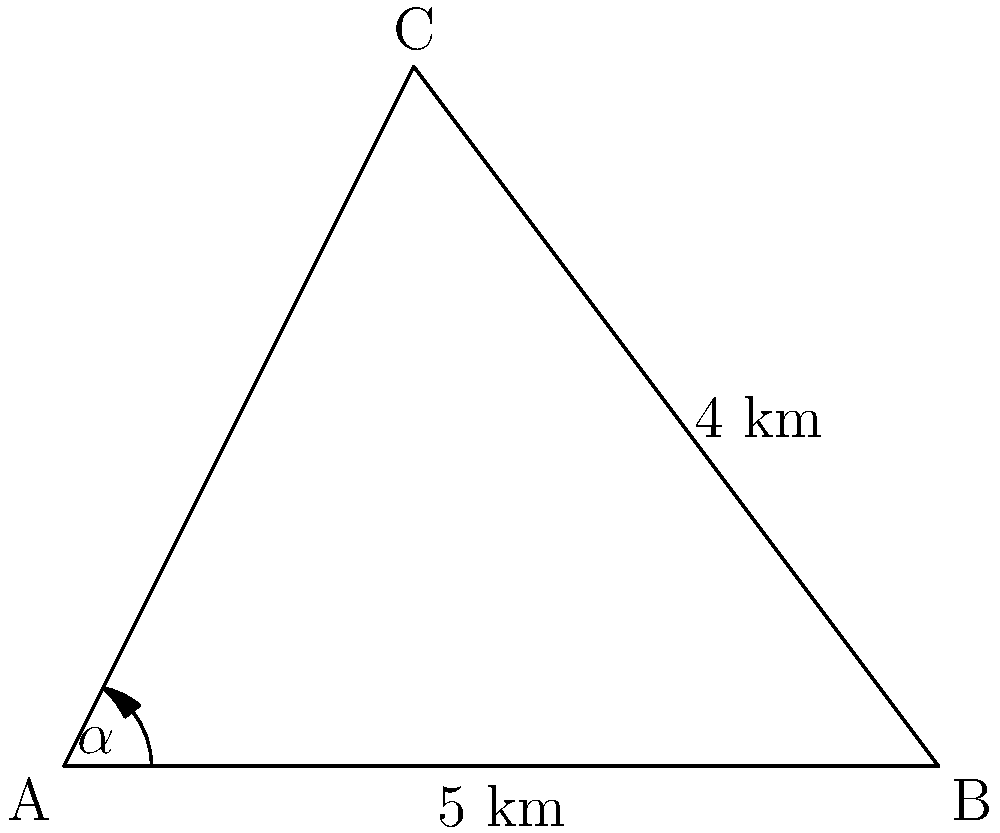As a tech-savvy parent, you're helping your child with a school project about local landmarks. You're standing at point A, and you can see two Franklin County landmarks: the school (point B) and the community center (point C). You know that the distance between you and the school is 5 km, and the distance between the school and the community center is 4 km. The angle between these two landmarks from your position ($\alpha$) is 53°. What is the distance between you and the community center? Let's solve this problem using the law of sines:

1) First, let's identify what we know:
   - Side c (AB) = 5 km
   - Side a (BC) = 4 km
   - Angle A ($\alpha$) = 53°

2) The law of sines states: 
   $$\frac{a}{\sin(A)} = \frac{b}{\sin(B)} = \frac{c}{\sin(C)}$$

3) We want to find side b (AC), so we'll use:
   $$\frac{a}{\sin(A)} = \frac{b}{\sin(B)}$$

4) Rearranging to solve for b:
   $$b = \frac{a \sin(B)}{\sin(A)}$$

5) We know a and A, but we don't know B. However, we can find C:
   C = 180° - A - B = 180° - 53° - B = 127° - B

6) Using the law of sines again:
   $$\frac{c}{\sin(C)} = \frac{a}{\sin(A)}$$

7) Substituting known values:
   $$\frac{5}{\sin(127° - B)} = \frac{4}{\sin(53°)}$$

8) Solving for B:
   $$B \approx 77.6°$$

9) Now we can use the formula from step 4:
   $$b = \frac{4 \sin(77.6°)}{\sin(53°)} \approx 5.4 \text{ km}$$

Thus, the distance between you (point A) and the community center (point C) is approximately 5.4 km.
Answer: 5.4 km 